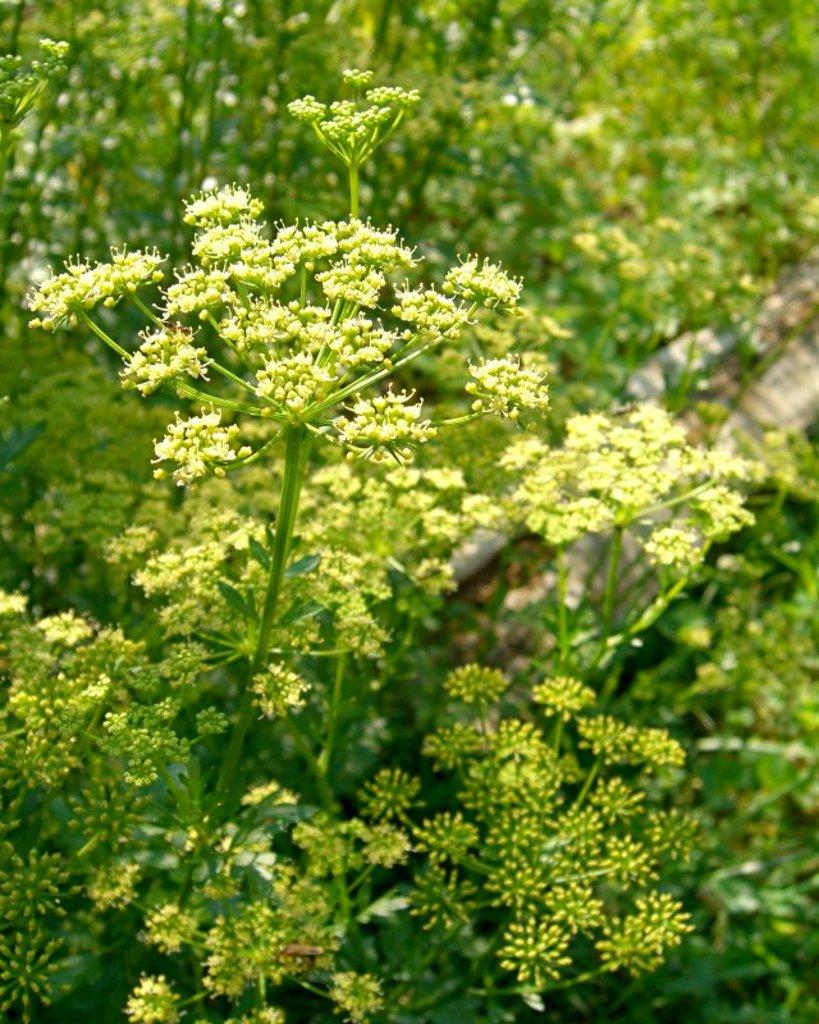What type of living organisms can be seen in the image? Flowers and plants are visible in the image. Can you describe the plants in the image? The image contains flowers, which are a type of plant. What type of drain is visible in the image? There is no drain present in the image. 